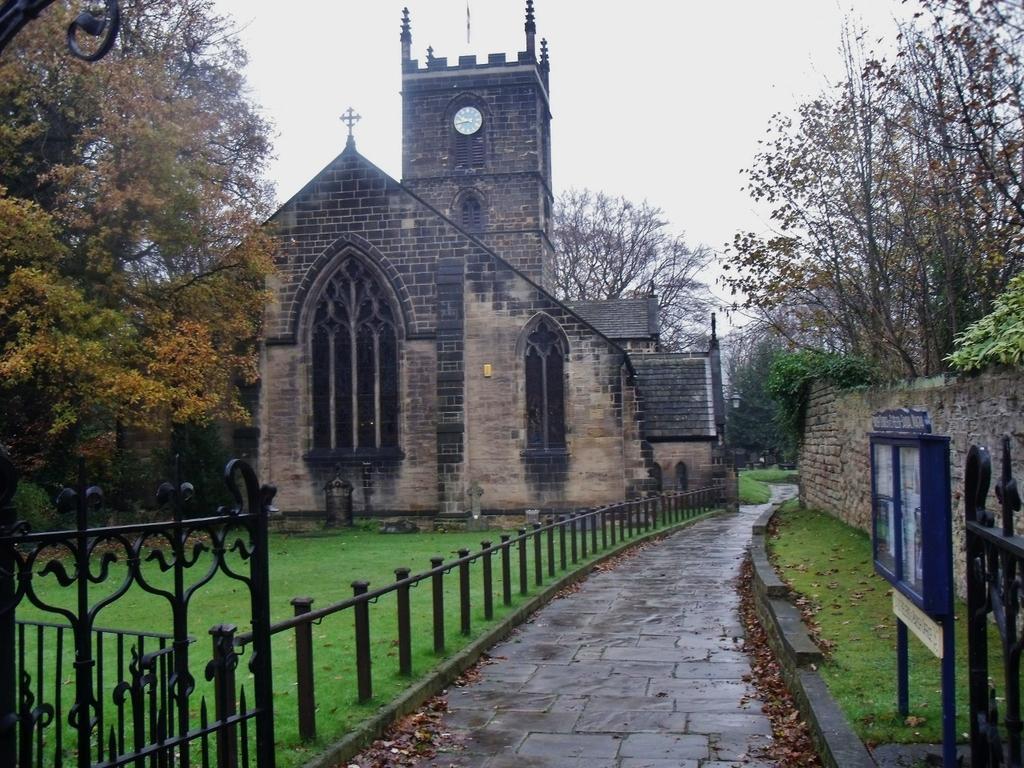Can you describe this image briefly? In this image I can see the road, few leaves on the ground, the railing, the wall, few trees which are green, brown and orange in color and few buildings which are brown and black in color. I can a clock to the building and in the background I can see the sky. 